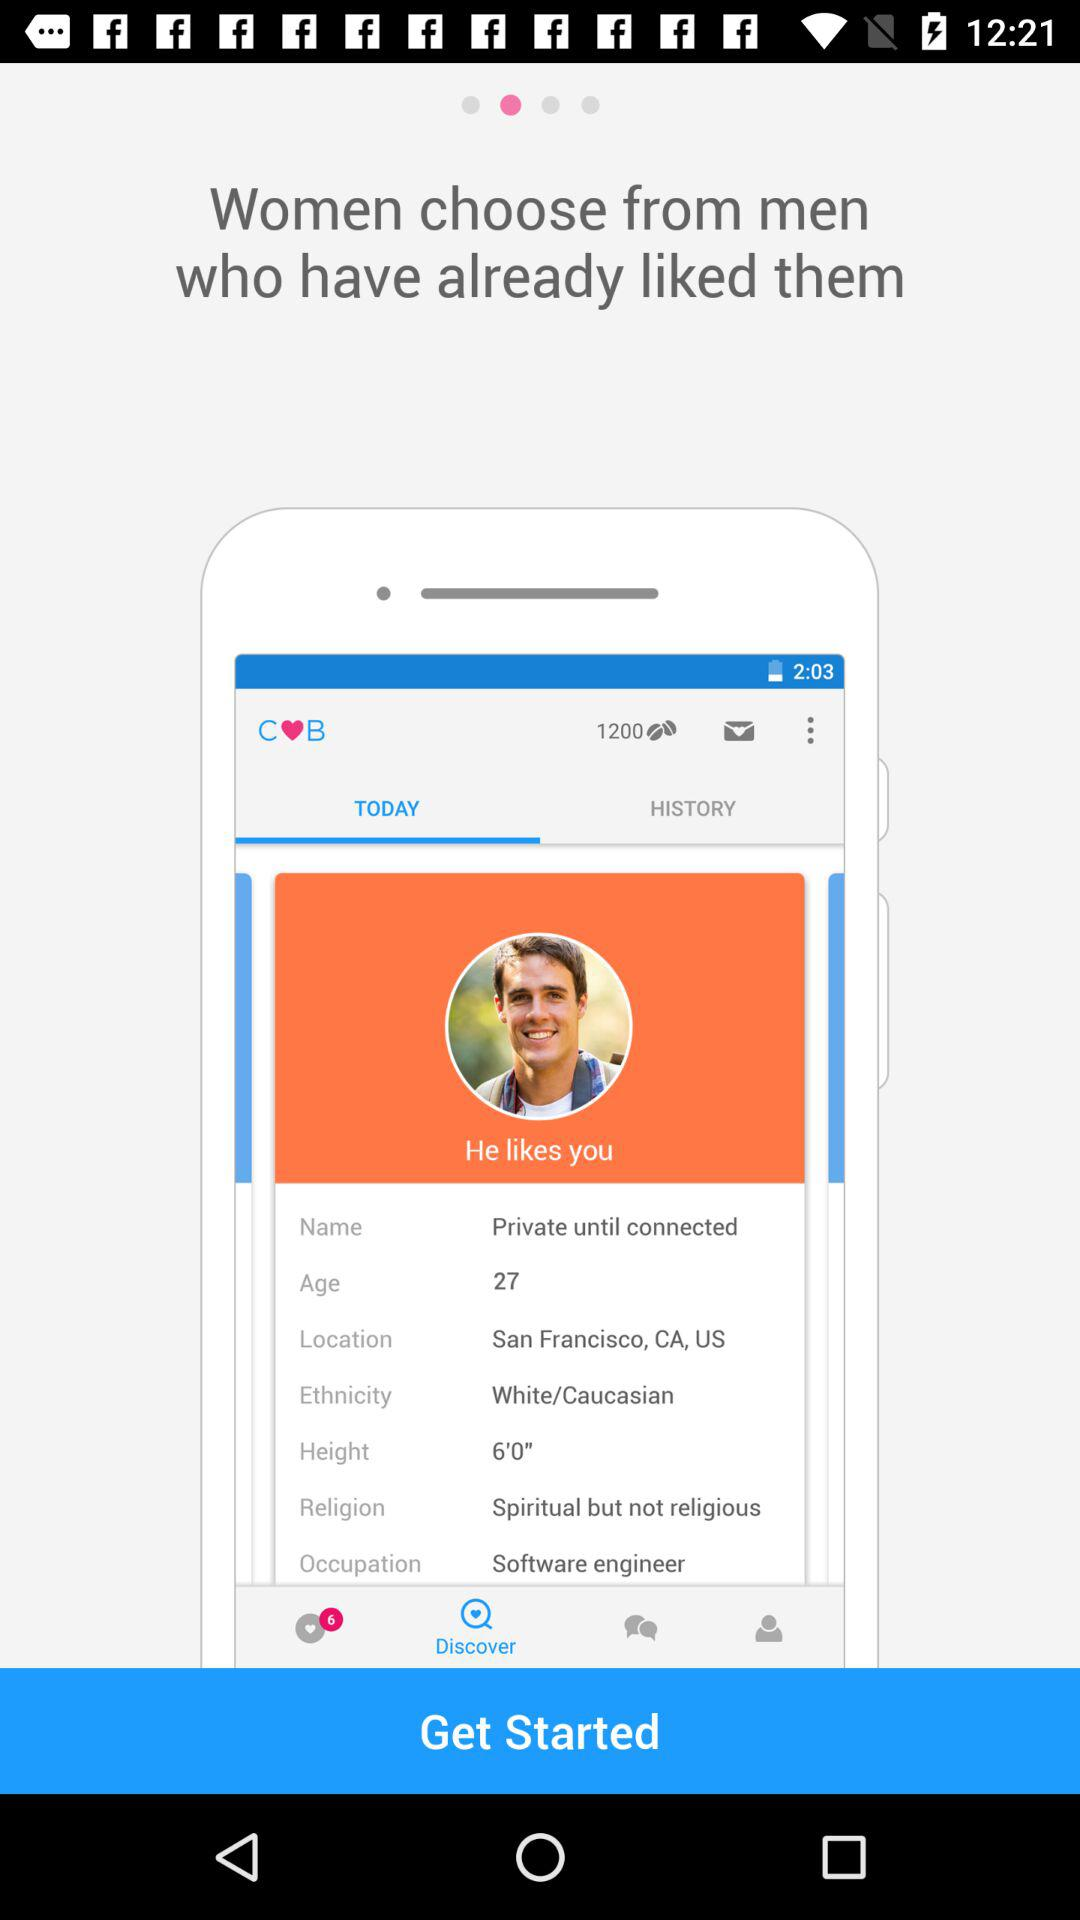What is the ethnicity of the man? The ethnicity of the man is White/Caucasian. 